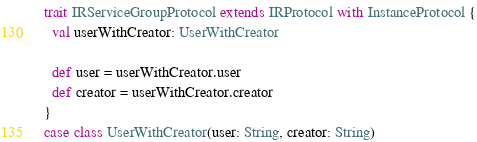<code> <loc_0><loc_0><loc_500><loc_500><_Scala_>
trait IRServiceGroupProtocol extends IRProtocol with InstanceProtocol {
  val userWithCreator: UserWithCreator

  def user = userWithCreator.user
  def creator = userWithCreator.creator
}
case class UserWithCreator(user: String, creator: String)</code> 